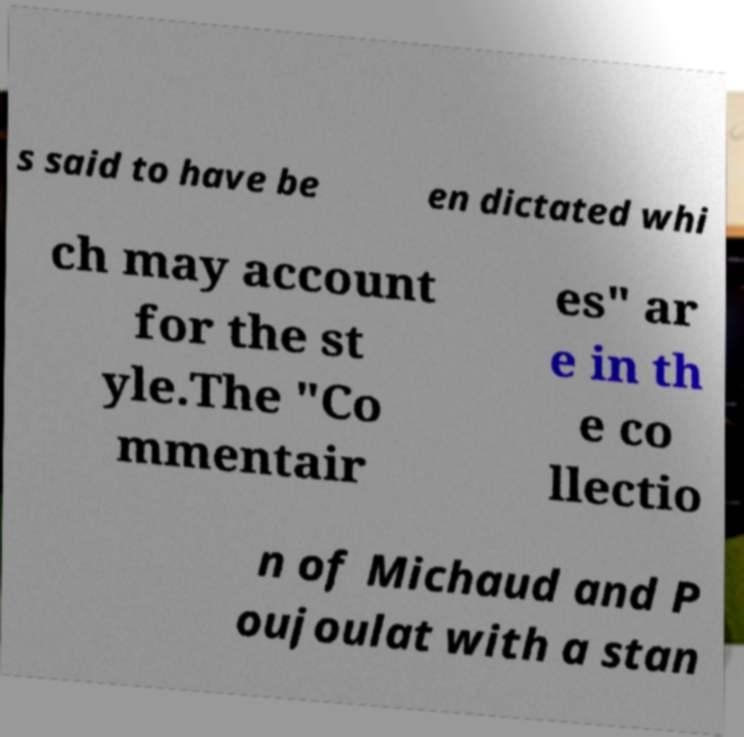There's text embedded in this image that I need extracted. Can you transcribe it verbatim? s said to have be en dictated whi ch may account for the st yle.The "Co mmentair es" ar e in th e co llectio n of Michaud and P oujoulat with a stan 